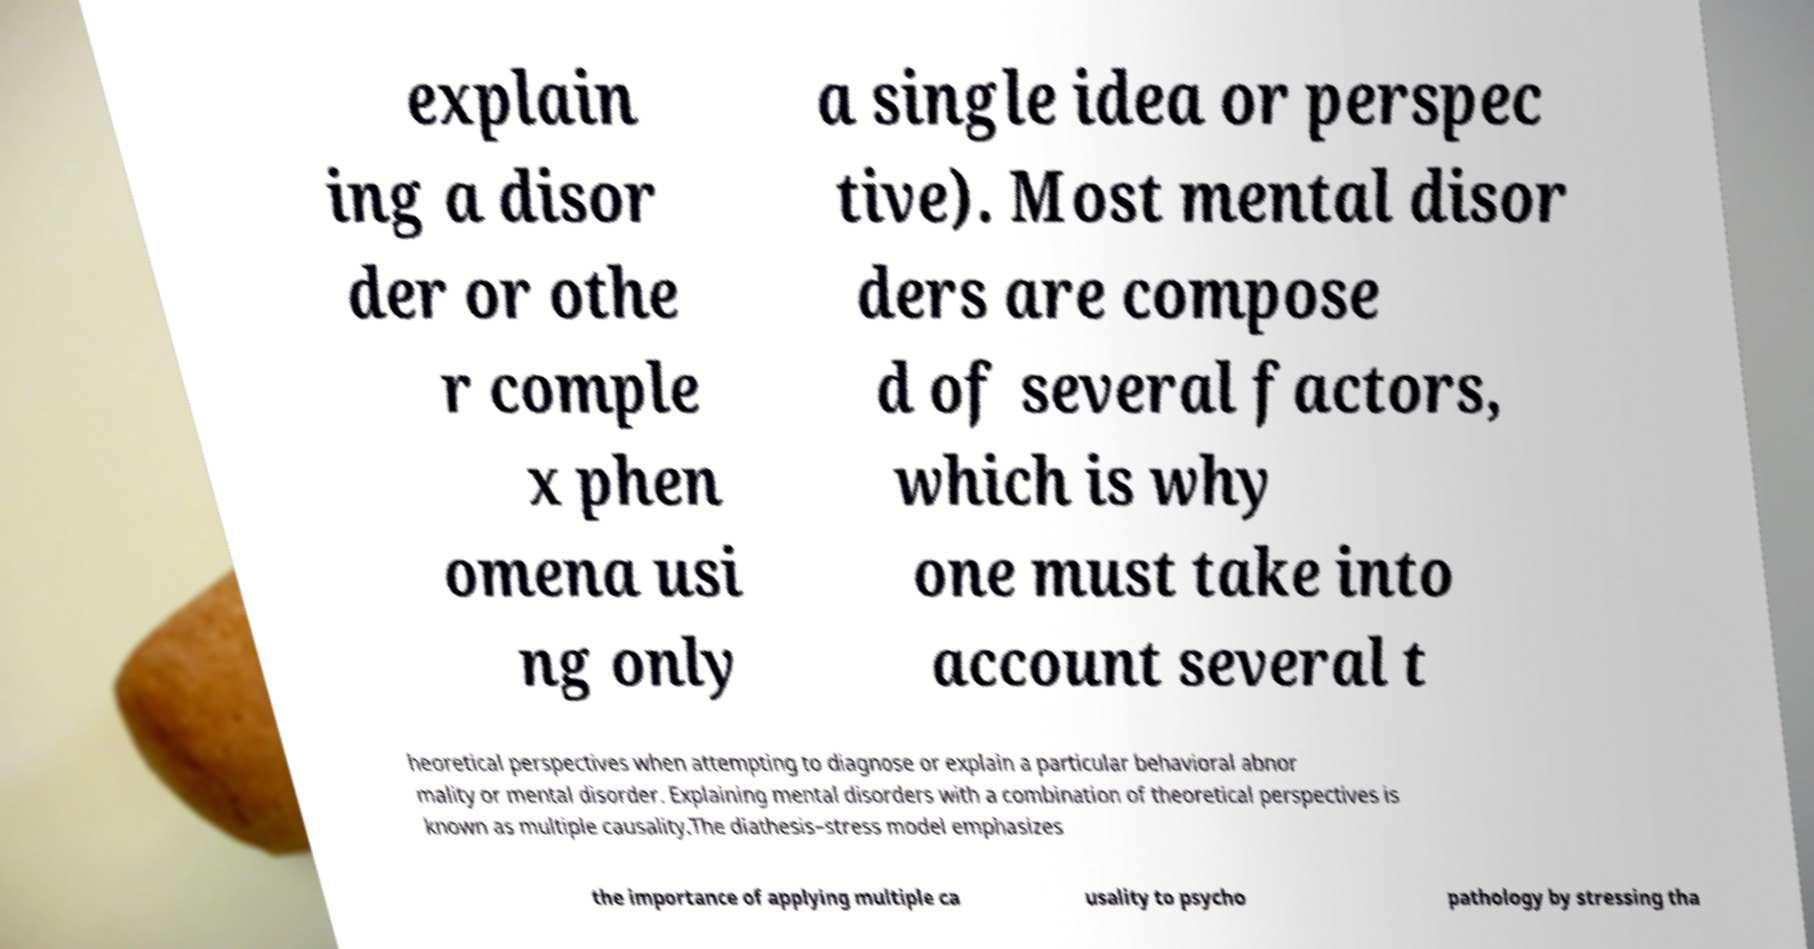Please identify and transcribe the text found in this image. explain ing a disor der or othe r comple x phen omena usi ng only a single idea or perspec tive). Most mental disor ders are compose d of several factors, which is why one must take into account several t heoretical perspectives when attempting to diagnose or explain a particular behavioral abnor mality or mental disorder. Explaining mental disorders with a combination of theoretical perspectives is known as multiple causality.The diathesis–stress model emphasizes the importance of applying multiple ca usality to psycho pathology by stressing tha 